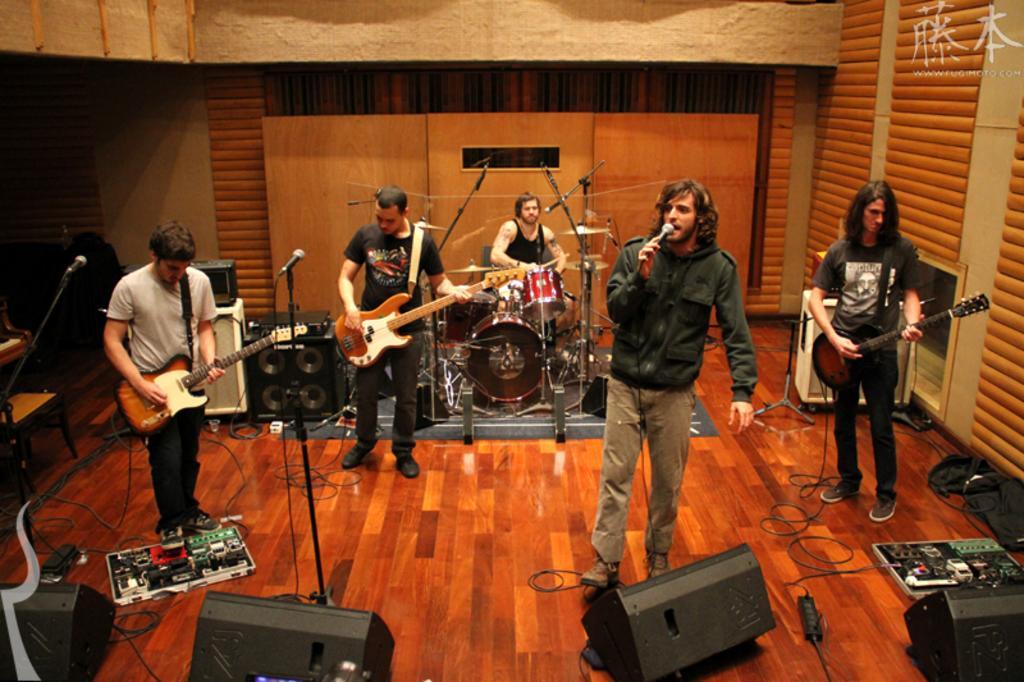Could you give a brief overview of what you see in this image? This is a room in which there are five people among them three are playing the guitar and the one is playing the band and the other holding the mike and singing. The floor and the background is in red brown color and there are also some speakers in the room. 